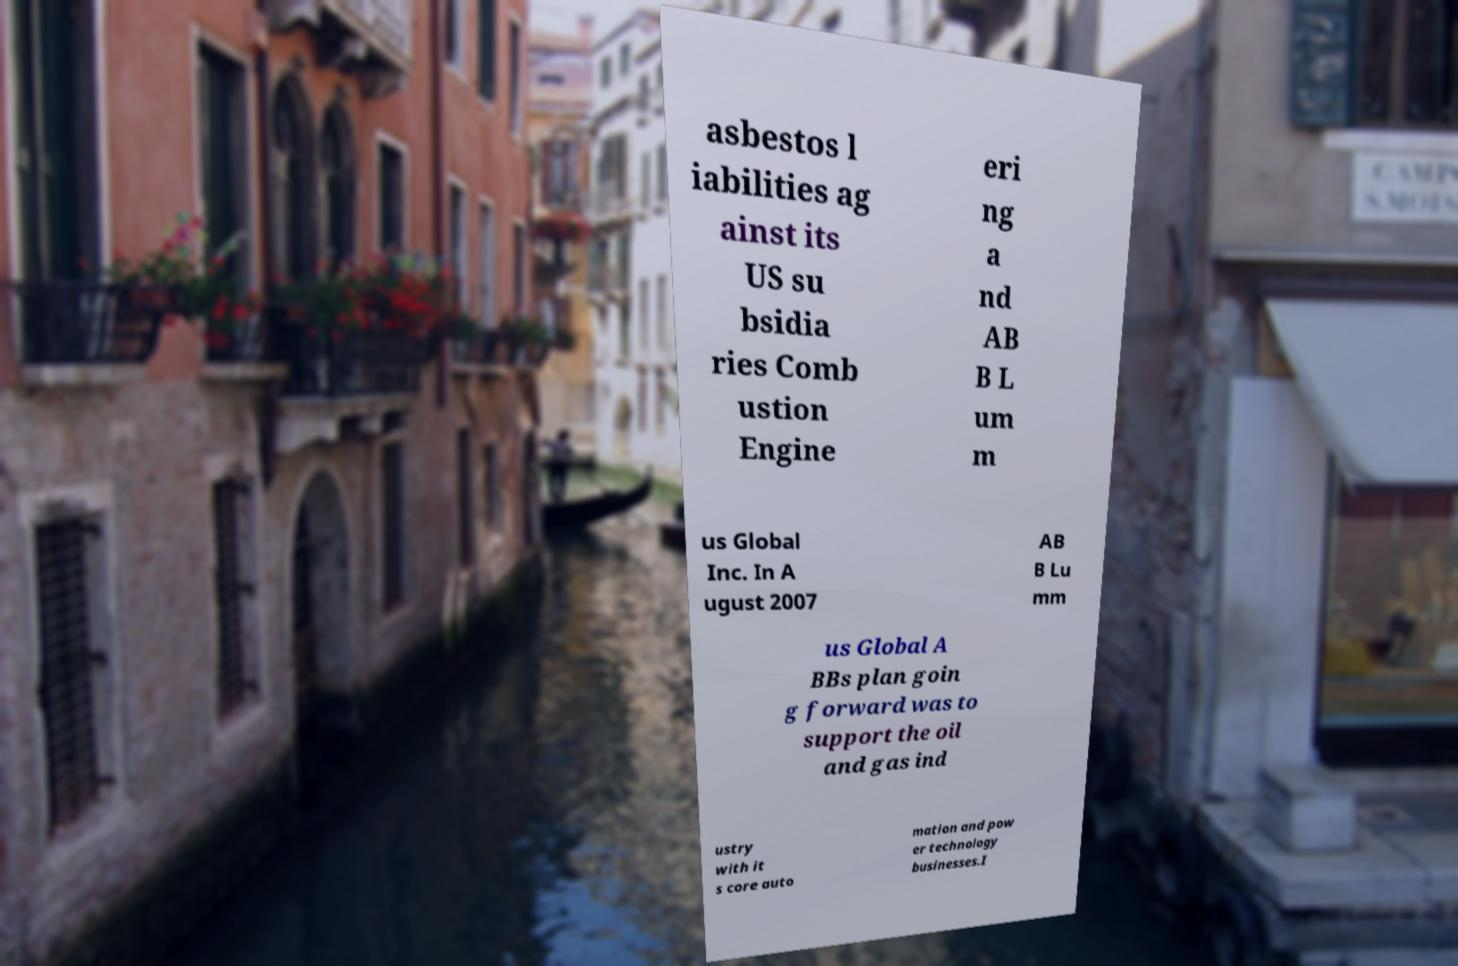Please identify and transcribe the text found in this image. asbestos l iabilities ag ainst its US su bsidia ries Comb ustion Engine eri ng a nd AB B L um m us Global Inc. In A ugust 2007 AB B Lu mm us Global A BBs plan goin g forward was to support the oil and gas ind ustry with it s core auto mation and pow er technology businesses.I 